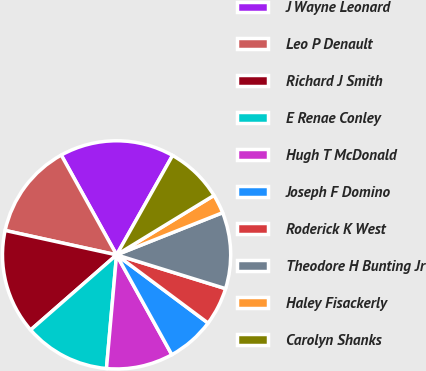Convert chart to OTSL. <chart><loc_0><loc_0><loc_500><loc_500><pie_chart><fcel>J Wayne Leonard<fcel>Leo P Denault<fcel>Richard J Smith<fcel>E Renae Conley<fcel>Hugh T McDonald<fcel>Joseph F Domino<fcel>Roderick K West<fcel>Theodore H Bunting Jr<fcel>Haley Fisackerly<fcel>Carolyn Shanks<nl><fcel>16.22%<fcel>13.51%<fcel>14.86%<fcel>12.16%<fcel>9.46%<fcel>6.76%<fcel>5.41%<fcel>10.81%<fcel>2.7%<fcel>8.11%<nl></chart> 